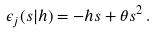<formula> <loc_0><loc_0><loc_500><loc_500>\epsilon _ { j } ( s | h ) = - h s + \theta s ^ { 2 } \, .</formula> 